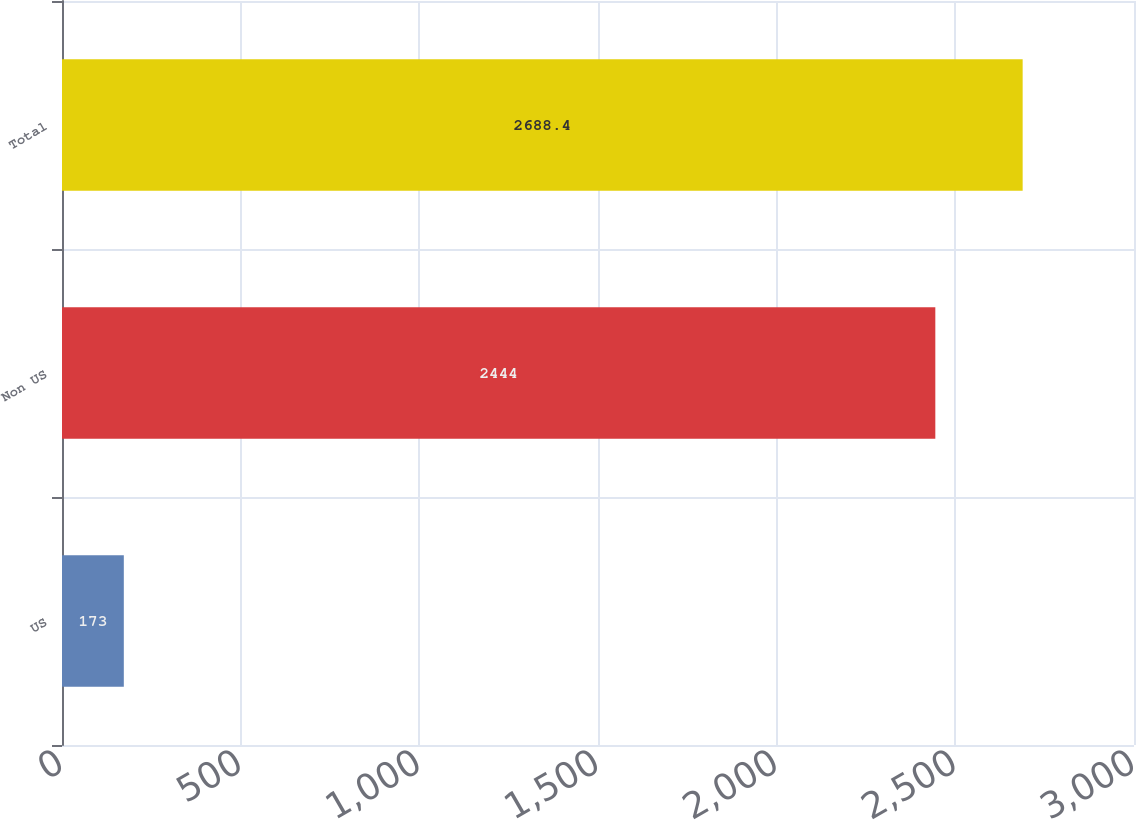Convert chart to OTSL. <chart><loc_0><loc_0><loc_500><loc_500><bar_chart><fcel>US<fcel>Non US<fcel>Total<nl><fcel>173<fcel>2444<fcel>2688.4<nl></chart> 